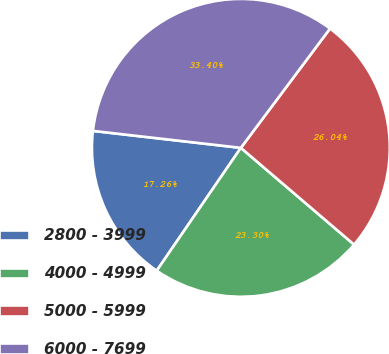Convert chart. <chart><loc_0><loc_0><loc_500><loc_500><pie_chart><fcel>2800 - 3999<fcel>4000 - 4999<fcel>5000 - 5999<fcel>6000 - 7699<nl><fcel>17.26%<fcel>23.3%<fcel>26.04%<fcel>33.4%<nl></chart> 